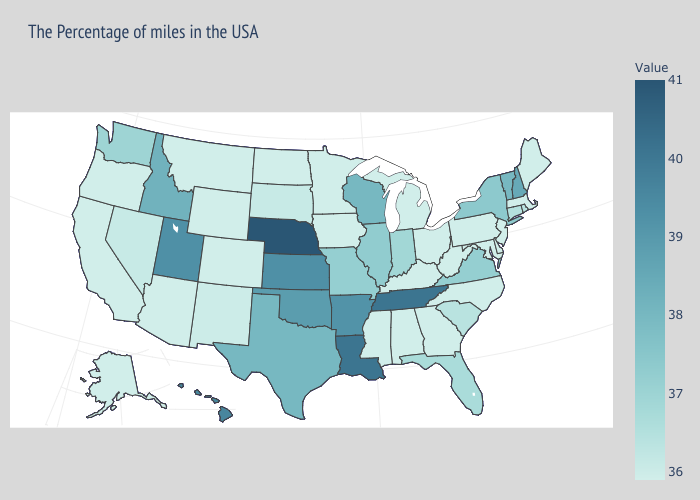Among the states that border New Jersey , does New York have the lowest value?
Give a very brief answer. No. Does New Mexico have a lower value than Illinois?
Write a very short answer. Yes. Does New Mexico have the lowest value in the West?
Keep it brief. No. Which states hav the highest value in the MidWest?
Keep it brief. Nebraska. 